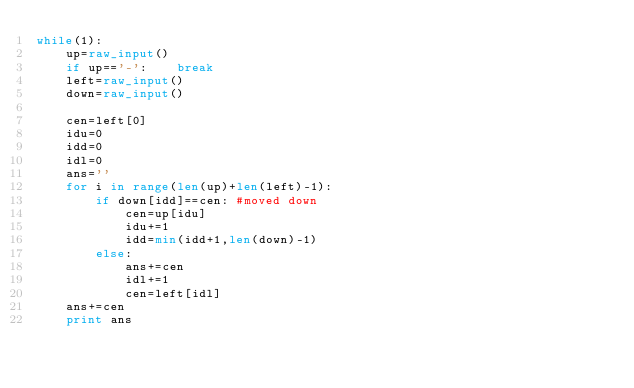<code> <loc_0><loc_0><loc_500><loc_500><_Python_>while(1):
    up=raw_input()
    if up=='-':    break
    left=raw_input()
    down=raw_input()
    
    cen=left[0]
    idu=0
    idd=0
    idl=0
    ans=''
    for i in range(len(up)+len(left)-1):
        if down[idd]==cen: #moved down
            cen=up[idu]
            idu+=1
            idd=min(idd+1,len(down)-1)
        else:
            ans+=cen
            idl+=1
            cen=left[idl]
    ans+=cen
    print ans</code> 